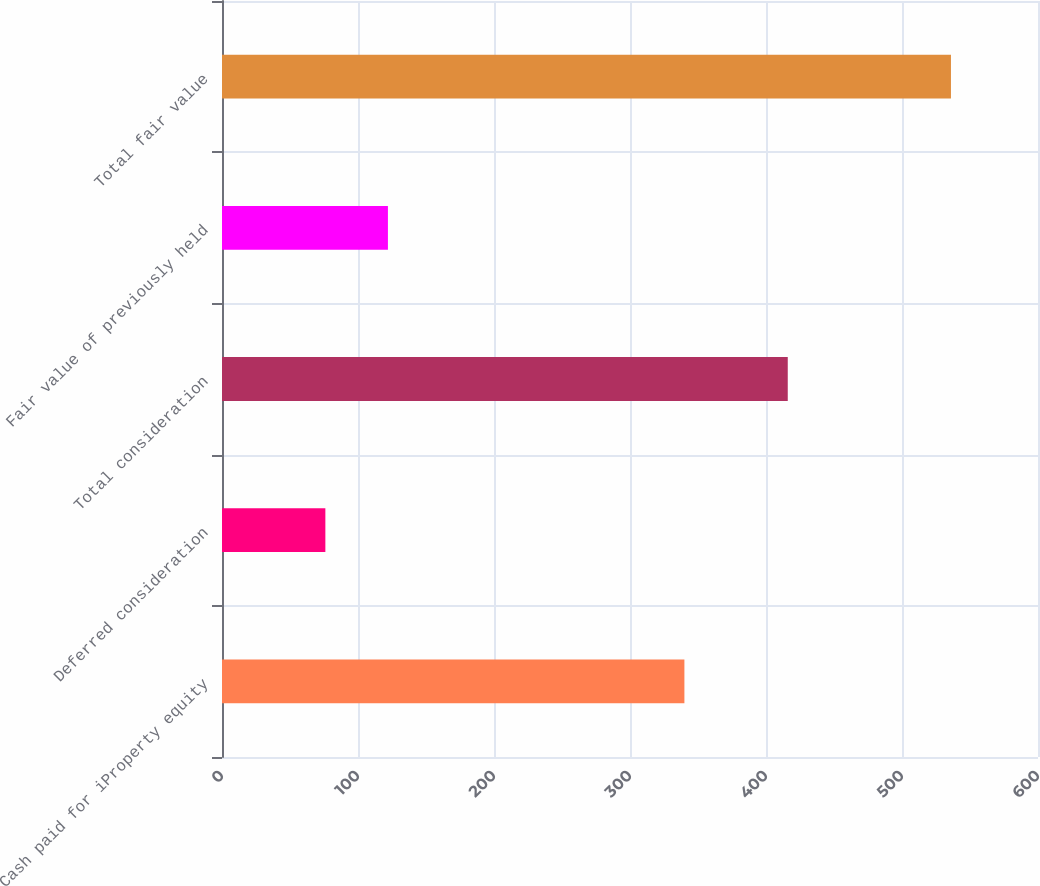<chart> <loc_0><loc_0><loc_500><loc_500><bar_chart><fcel>Cash paid for iProperty equity<fcel>Deferred consideration<fcel>Total consideration<fcel>Fair value of previously held<fcel>Total fair value<nl><fcel>340<fcel>76<fcel>416<fcel>122<fcel>536<nl></chart> 